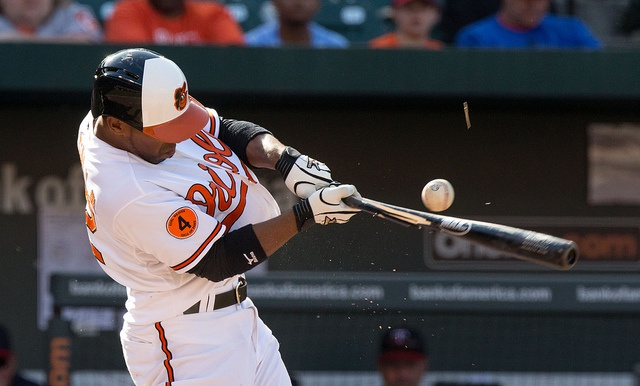Describe the objects in this image and their specific colors. I can see people in black, lavender, darkgray, and maroon tones, people in black, brown, and maroon tones, people in black, navy, darkblue, and maroon tones, baseball bat in black, gray, lightgray, and darkgray tones, and people in black and gray tones in this image. 